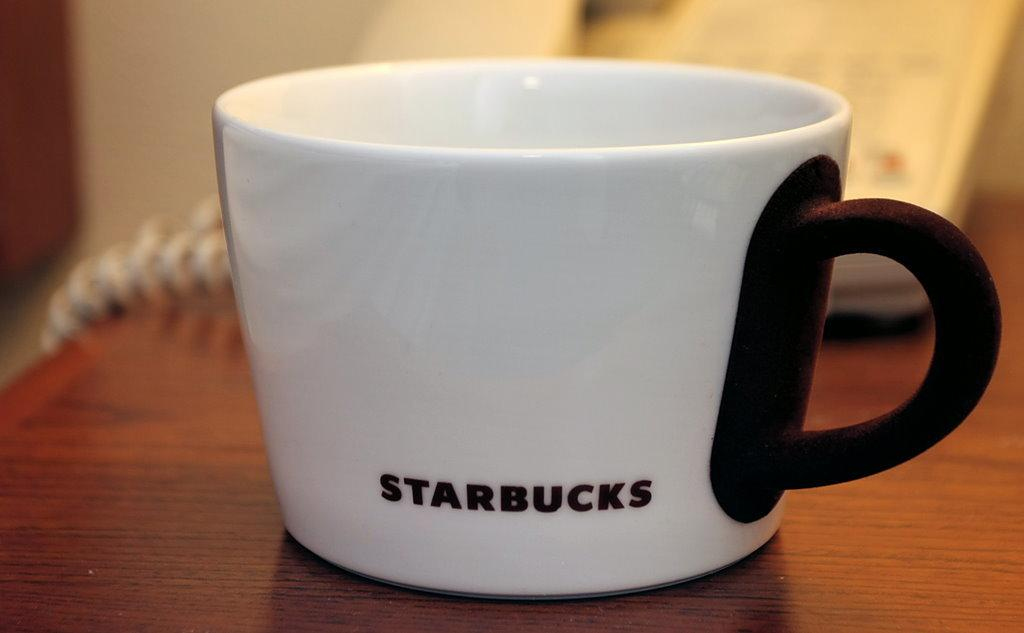<image>
Relay a brief, clear account of the picture shown. A white cup with a brown handle and Starbucks printed on it sits alone on a wooden table. 